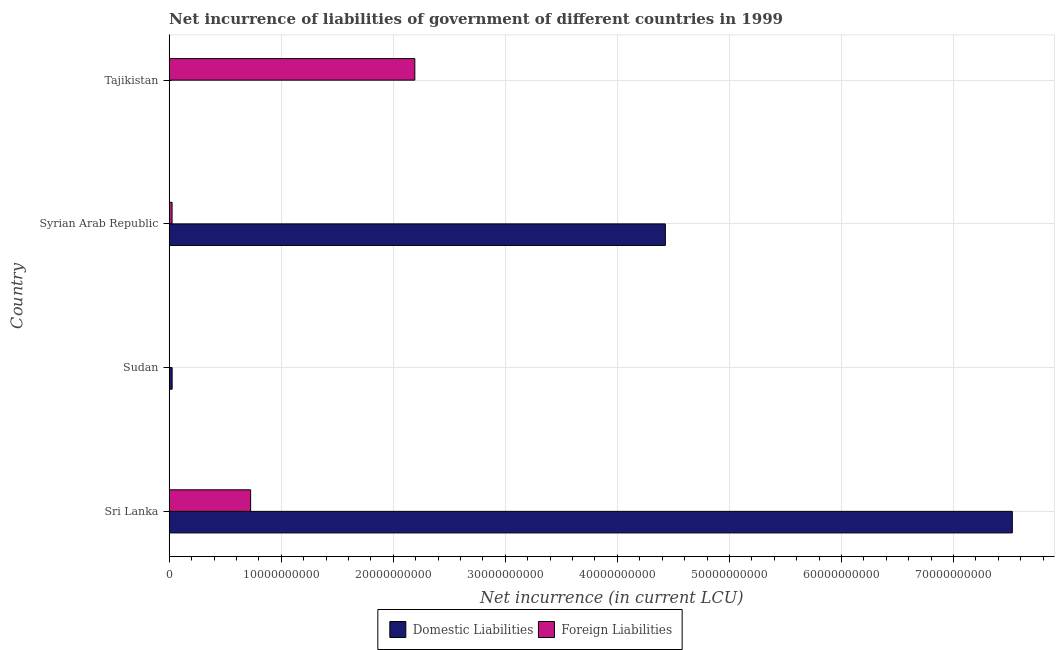How many different coloured bars are there?
Provide a succinct answer. 2. Are the number of bars per tick equal to the number of legend labels?
Keep it short and to the point. No. Are the number of bars on each tick of the Y-axis equal?
Your response must be concise. No. How many bars are there on the 4th tick from the top?
Your answer should be compact. 2. How many bars are there on the 1st tick from the bottom?
Your answer should be very brief. 2. What is the label of the 2nd group of bars from the top?
Your answer should be very brief. Syrian Arab Republic. In how many cases, is the number of bars for a given country not equal to the number of legend labels?
Give a very brief answer. 2. What is the net incurrence of domestic liabilities in Syrian Arab Republic?
Your answer should be compact. 4.43e+1. Across all countries, what is the maximum net incurrence of foreign liabilities?
Give a very brief answer. 2.19e+1. In which country was the net incurrence of domestic liabilities maximum?
Make the answer very short. Sri Lanka. What is the total net incurrence of domestic liabilities in the graph?
Make the answer very short. 1.20e+11. What is the difference between the net incurrence of domestic liabilities in Sudan and that in Syrian Arab Republic?
Provide a succinct answer. -4.40e+1. What is the difference between the net incurrence of domestic liabilities in Syrian Arab Republic and the net incurrence of foreign liabilities in Sri Lanka?
Make the answer very short. 3.70e+1. What is the average net incurrence of domestic liabilities per country?
Your answer should be very brief. 2.99e+1. What is the difference between the net incurrence of domestic liabilities and net incurrence of foreign liabilities in Sri Lanka?
Provide a succinct answer. 6.80e+1. In how many countries, is the net incurrence of foreign liabilities greater than 62000000000 LCU?
Provide a short and direct response. 0. What is the ratio of the net incurrence of foreign liabilities in Sri Lanka to that in Tajikistan?
Make the answer very short. 0.33. Is the net incurrence of foreign liabilities in Sri Lanka less than that in Syrian Arab Republic?
Give a very brief answer. No. Is the difference between the net incurrence of foreign liabilities in Sri Lanka and Syrian Arab Republic greater than the difference between the net incurrence of domestic liabilities in Sri Lanka and Syrian Arab Republic?
Keep it short and to the point. No. What is the difference between the highest and the second highest net incurrence of domestic liabilities?
Offer a very short reply. 3.10e+1. What is the difference between the highest and the lowest net incurrence of foreign liabilities?
Make the answer very short. 2.19e+1. Is the sum of the net incurrence of domestic liabilities in Sri Lanka and Sudan greater than the maximum net incurrence of foreign liabilities across all countries?
Keep it short and to the point. Yes. Are all the bars in the graph horizontal?
Offer a very short reply. Yes. What is the difference between two consecutive major ticks on the X-axis?
Offer a very short reply. 1.00e+1. Are the values on the major ticks of X-axis written in scientific E-notation?
Provide a short and direct response. No. What is the title of the graph?
Offer a terse response. Net incurrence of liabilities of government of different countries in 1999. What is the label or title of the X-axis?
Your answer should be compact. Net incurrence (in current LCU). What is the label or title of the Y-axis?
Offer a terse response. Country. What is the Net incurrence (in current LCU) of Domestic Liabilities in Sri Lanka?
Ensure brevity in your answer.  7.53e+1. What is the Net incurrence (in current LCU) of Foreign Liabilities in Sri Lanka?
Provide a succinct answer. 7.27e+09. What is the Net incurrence (in current LCU) of Domestic Liabilities in Sudan?
Provide a succinct answer. 2.62e+08. What is the Net incurrence (in current LCU) in Foreign Liabilities in Sudan?
Provide a short and direct response. 0. What is the Net incurrence (in current LCU) in Domestic Liabilities in Syrian Arab Republic?
Your answer should be compact. 4.43e+1. What is the Net incurrence (in current LCU) in Foreign Liabilities in Syrian Arab Republic?
Provide a succinct answer. 2.56e+08. What is the Net incurrence (in current LCU) in Domestic Liabilities in Tajikistan?
Your response must be concise. 0. What is the Net incurrence (in current LCU) in Foreign Liabilities in Tajikistan?
Ensure brevity in your answer.  2.19e+1. Across all countries, what is the maximum Net incurrence (in current LCU) in Domestic Liabilities?
Offer a terse response. 7.53e+1. Across all countries, what is the maximum Net incurrence (in current LCU) in Foreign Liabilities?
Your response must be concise. 2.19e+1. Across all countries, what is the minimum Net incurrence (in current LCU) in Domestic Liabilities?
Provide a short and direct response. 0. What is the total Net incurrence (in current LCU) in Domestic Liabilities in the graph?
Make the answer very short. 1.20e+11. What is the total Net incurrence (in current LCU) in Foreign Liabilities in the graph?
Give a very brief answer. 2.94e+1. What is the difference between the Net incurrence (in current LCU) in Domestic Liabilities in Sri Lanka and that in Sudan?
Ensure brevity in your answer.  7.50e+1. What is the difference between the Net incurrence (in current LCU) of Domestic Liabilities in Sri Lanka and that in Syrian Arab Republic?
Offer a terse response. 3.10e+1. What is the difference between the Net incurrence (in current LCU) in Foreign Liabilities in Sri Lanka and that in Syrian Arab Republic?
Ensure brevity in your answer.  7.01e+09. What is the difference between the Net incurrence (in current LCU) of Foreign Liabilities in Sri Lanka and that in Tajikistan?
Your response must be concise. -1.47e+1. What is the difference between the Net incurrence (in current LCU) of Domestic Liabilities in Sudan and that in Syrian Arab Republic?
Offer a terse response. -4.40e+1. What is the difference between the Net incurrence (in current LCU) in Foreign Liabilities in Syrian Arab Republic and that in Tajikistan?
Give a very brief answer. -2.17e+1. What is the difference between the Net incurrence (in current LCU) in Domestic Liabilities in Sri Lanka and the Net incurrence (in current LCU) in Foreign Liabilities in Syrian Arab Republic?
Make the answer very short. 7.50e+1. What is the difference between the Net incurrence (in current LCU) of Domestic Liabilities in Sri Lanka and the Net incurrence (in current LCU) of Foreign Liabilities in Tajikistan?
Your response must be concise. 5.33e+1. What is the difference between the Net incurrence (in current LCU) in Domestic Liabilities in Sudan and the Net incurrence (in current LCU) in Foreign Liabilities in Syrian Arab Republic?
Provide a succinct answer. 5.85e+06. What is the difference between the Net incurrence (in current LCU) of Domestic Liabilities in Sudan and the Net incurrence (in current LCU) of Foreign Liabilities in Tajikistan?
Offer a very short reply. -2.17e+1. What is the difference between the Net incurrence (in current LCU) of Domestic Liabilities in Syrian Arab Republic and the Net incurrence (in current LCU) of Foreign Liabilities in Tajikistan?
Ensure brevity in your answer.  2.24e+1. What is the average Net incurrence (in current LCU) of Domestic Liabilities per country?
Make the answer very short. 2.99e+1. What is the average Net incurrence (in current LCU) of Foreign Liabilities per country?
Offer a terse response. 7.36e+09. What is the difference between the Net incurrence (in current LCU) of Domestic Liabilities and Net incurrence (in current LCU) of Foreign Liabilities in Sri Lanka?
Give a very brief answer. 6.80e+1. What is the difference between the Net incurrence (in current LCU) of Domestic Liabilities and Net incurrence (in current LCU) of Foreign Liabilities in Syrian Arab Republic?
Your answer should be compact. 4.40e+1. What is the ratio of the Net incurrence (in current LCU) in Domestic Liabilities in Sri Lanka to that in Sudan?
Provide a succinct answer. 287.14. What is the ratio of the Net incurrence (in current LCU) of Domestic Liabilities in Sri Lanka to that in Syrian Arab Republic?
Offer a very short reply. 1.7. What is the ratio of the Net incurrence (in current LCU) of Foreign Liabilities in Sri Lanka to that in Syrian Arab Republic?
Make the answer very short. 28.36. What is the ratio of the Net incurrence (in current LCU) in Foreign Liabilities in Sri Lanka to that in Tajikistan?
Make the answer very short. 0.33. What is the ratio of the Net incurrence (in current LCU) of Domestic Liabilities in Sudan to that in Syrian Arab Republic?
Make the answer very short. 0.01. What is the ratio of the Net incurrence (in current LCU) of Foreign Liabilities in Syrian Arab Republic to that in Tajikistan?
Give a very brief answer. 0.01. What is the difference between the highest and the second highest Net incurrence (in current LCU) of Domestic Liabilities?
Provide a short and direct response. 3.10e+1. What is the difference between the highest and the second highest Net incurrence (in current LCU) of Foreign Liabilities?
Your answer should be very brief. 1.47e+1. What is the difference between the highest and the lowest Net incurrence (in current LCU) in Domestic Liabilities?
Keep it short and to the point. 7.53e+1. What is the difference between the highest and the lowest Net incurrence (in current LCU) in Foreign Liabilities?
Offer a very short reply. 2.19e+1. 